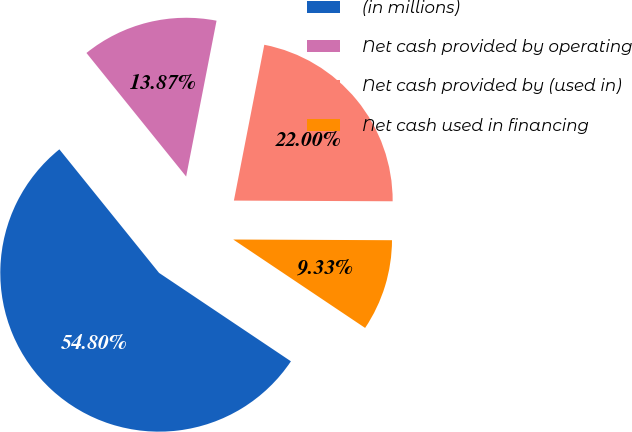Convert chart to OTSL. <chart><loc_0><loc_0><loc_500><loc_500><pie_chart><fcel>(in millions)<fcel>Net cash provided by operating<fcel>Net cash provided by (used in)<fcel>Net cash used in financing<nl><fcel>54.79%<fcel>13.87%<fcel>22.0%<fcel>9.33%<nl></chart> 